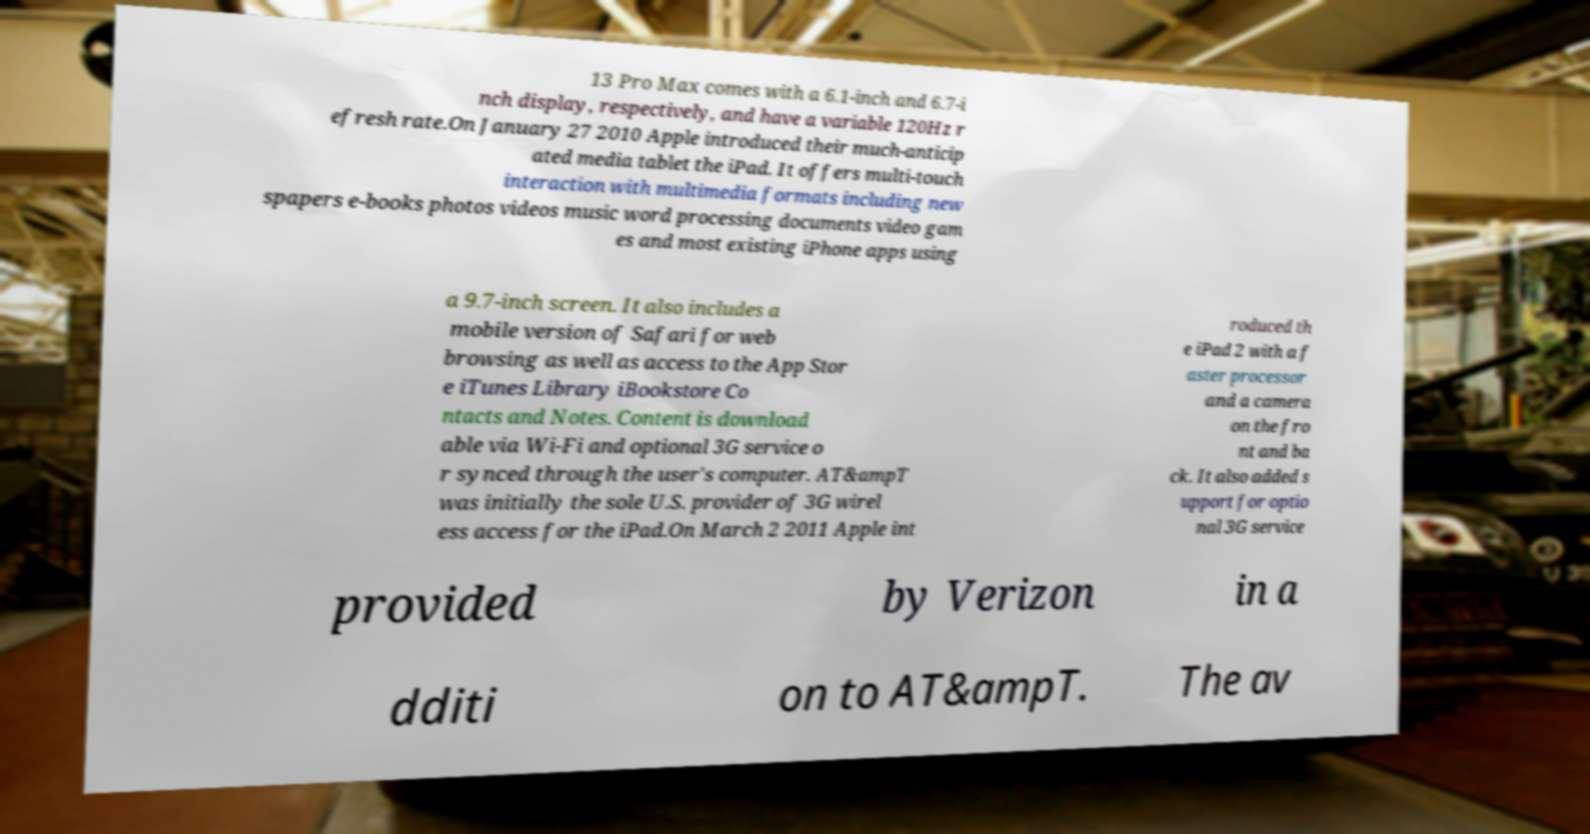There's text embedded in this image that I need extracted. Can you transcribe it verbatim? 13 Pro Max comes with a 6.1-inch and 6.7-i nch display, respectively, and have a variable 120Hz r efresh rate.On January 27 2010 Apple introduced their much-anticip ated media tablet the iPad. It offers multi-touch interaction with multimedia formats including new spapers e-books photos videos music word processing documents video gam es and most existing iPhone apps using a 9.7-inch screen. It also includes a mobile version of Safari for web browsing as well as access to the App Stor e iTunes Library iBookstore Co ntacts and Notes. Content is download able via Wi-Fi and optional 3G service o r synced through the user's computer. AT&ampT was initially the sole U.S. provider of 3G wirel ess access for the iPad.On March 2 2011 Apple int roduced th e iPad 2 with a f aster processor and a camera on the fro nt and ba ck. It also added s upport for optio nal 3G service provided by Verizon in a dditi on to AT&ampT. The av 